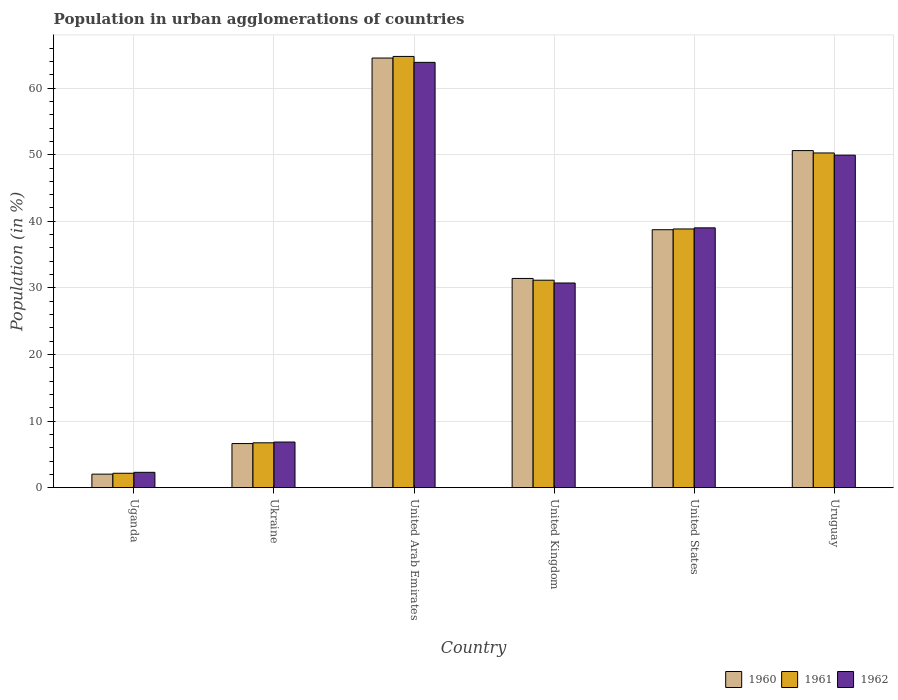How many different coloured bars are there?
Keep it short and to the point. 3. How many groups of bars are there?
Make the answer very short. 6. Are the number of bars on each tick of the X-axis equal?
Provide a short and direct response. Yes. How many bars are there on the 2nd tick from the right?
Your answer should be very brief. 3. What is the percentage of population in urban agglomerations in 1961 in Ukraine?
Give a very brief answer. 6.73. Across all countries, what is the maximum percentage of population in urban agglomerations in 1961?
Offer a very short reply. 64.75. Across all countries, what is the minimum percentage of population in urban agglomerations in 1962?
Provide a succinct answer. 2.3. In which country was the percentage of population in urban agglomerations in 1962 maximum?
Provide a short and direct response. United Arab Emirates. In which country was the percentage of population in urban agglomerations in 1962 minimum?
Give a very brief answer. Uganda. What is the total percentage of population in urban agglomerations in 1962 in the graph?
Offer a very short reply. 192.69. What is the difference between the percentage of population in urban agglomerations in 1960 in Ukraine and that in Uruguay?
Your answer should be compact. -44. What is the difference between the percentage of population in urban agglomerations in 1962 in United States and the percentage of population in urban agglomerations in 1961 in Uruguay?
Your answer should be very brief. -11.24. What is the average percentage of population in urban agglomerations in 1960 per country?
Your answer should be compact. 32.32. What is the difference between the percentage of population in urban agglomerations of/in 1960 and percentage of population in urban agglomerations of/in 1962 in United Arab Emirates?
Your answer should be compact. 0.65. What is the ratio of the percentage of population in urban agglomerations in 1962 in Ukraine to that in Uruguay?
Provide a succinct answer. 0.14. Is the difference between the percentage of population in urban agglomerations in 1960 in Ukraine and United States greater than the difference between the percentage of population in urban agglomerations in 1962 in Ukraine and United States?
Keep it short and to the point. Yes. What is the difference between the highest and the second highest percentage of population in urban agglomerations in 1960?
Give a very brief answer. 13.9. What is the difference between the highest and the lowest percentage of population in urban agglomerations in 1960?
Ensure brevity in your answer.  62.49. In how many countries, is the percentage of population in urban agglomerations in 1961 greater than the average percentage of population in urban agglomerations in 1961 taken over all countries?
Your response must be concise. 3. Is the sum of the percentage of population in urban agglomerations in 1961 in United Arab Emirates and United States greater than the maximum percentage of population in urban agglomerations in 1962 across all countries?
Offer a very short reply. Yes. How many bars are there?
Provide a succinct answer. 18. Are all the bars in the graph horizontal?
Offer a terse response. No. Are the values on the major ticks of Y-axis written in scientific E-notation?
Ensure brevity in your answer.  No. Does the graph contain any zero values?
Your answer should be very brief. No. Where does the legend appear in the graph?
Ensure brevity in your answer.  Bottom right. What is the title of the graph?
Give a very brief answer. Population in urban agglomerations of countries. Does "2009" appear as one of the legend labels in the graph?
Give a very brief answer. No. What is the label or title of the Y-axis?
Provide a short and direct response. Population (in %). What is the Population (in %) of 1960 in Uganda?
Give a very brief answer. 2.03. What is the Population (in %) in 1961 in Uganda?
Give a very brief answer. 2.16. What is the Population (in %) in 1962 in Uganda?
Provide a short and direct response. 2.3. What is the Population (in %) of 1960 in Ukraine?
Give a very brief answer. 6.62. What is the Population (in %) of 1961 in Ukraine?
Your response must be concise. 6.73. What is the Population (in %) of 1962 in Ukraine?
Offer a very short reply. 6.85. What is the Population (in %) in 1960 in United Arab Emirates?
Your response must be concise. 64.51. What is the Population (in %) in 1961 in United Arab Emirates?
Give a very brief answer. 64.75. What is the Population (in %) in 1962 in United Arab Emirates?
Offer a very short reply. 63.86. What is the Population (in %) of 1960 in United Kingdom?
Give a very brief answer. 31.42. What is the Population (in %) in 1961 in United Kingdom?
Your response must be concise. 31.15. What is the Population (in %) of 1962 in United Kingdom?
Provide a short and direct response. 30.73. What is the Population (in %) in 1960 in United States?
Provide a succinct answer. 38.73. What is the Population (in %) of 1961 in United States?
Make the answer very short. 38.85. What is the Population (in %) of 1962 in United States?
Provide a succinct answer. 39.01. What is the Population (in %) of 1960 in Uruguay?
Make the answer very short. 50.62. What is the Population (in %) of 1961 in Uruguay?
Your answer should be very brief. 50.26. What is the Population (in %) in 1962 in Uruguay?
Give a very brief answer. 49.93. Across all countries, what is the maximum Population (in %) of 1960?
Keep it short and to the point. 64.51. Across all countries, what is the maximum Population (in %) of 1961?
Ensure brevity in your answer.  64.75. Across all countries, what is the maximum Population (in %) in 1962?
Your response must be concise. 63.86. Across all countries, what is the minimum Population (in %) of 1960?
Ensure brevity in your answer.  2.03. Across all countries, what is the minimum Population (in %) in 1961?
Ensure brevity in your answer.  2.16. Across all countries, what is the minimum Population (in %) in 1962?
Provide a short and direct response. 2.3. What is the total Population (in %) in 1960 in the graph?
Offer a very short reply. 193.92. What is the total Population (in %) in 1961 in the graph?
Make the answer very short. 193.9. What is the total Population (in %) in 1962 in the graph?
Give a very brief answer. 192.69. What is the difference between the Population (in %) in 1960 in Uganda and that in Ukraine?
Ensure brevity in your answer.  -4.6. What is the difference between the Population (in %) in 1961 in Uganda and that in Ukraine?
Give a very brief answer. -4.57. What is the difference between the Population (in %) in 1962 in Uganda and that in Ukraine?
Keep it short and to the point. -4.55. What is the difference between the Population (in %) in 1960 in Uganda and that in United Arab Emirates?
Keep it short and to the point. -62.49. What is the difference between the Population (in %) in 1961 in Uganda and that in United Arab Emirates?
Provide a short and direct response. -62.59. What is the difference between the Population (in %) in 1962 in Uganda and that in United Arab Emirates?
Keep it short and to the point. -61.56. What is the difference between the Population (in %) of 1960 in Uganda and that in United Kingdom?
Provide a short and direct response. -29.39. What is the difference between the Population (in %) of 1961 in Uganda and that in United Kingdom?
Offer a terse response. -28.99. What is the difference between the Population (in %) of 1962 in Uganda and that in United Kingdom?
Offer a very short reply. -28.43. What is the difference between the Population (in %) of 1960 in Uganda and that in United States?
Offer a terse response. -36.71. What is the difference between the Population (in %) of 1961 in Uganda and that in United States?
Offer a terse response. -36.69. What is the difference between the Population (in %) in 1962 in Uganda and that in United States?
Your answer should be very brief. -36.71. What is the difference between the Population (in %) in 1960 in Uganda and that in Uruguay?
Give a very brief answer. -48.59. What is the difference between the Population (in %) of 1961 in Uganda and that in Uruguay?
Provide a short and direct response. -48.1. What is the difference between the Population (in %) in 1962 in Uganda and that in Uruguay?
Provide a short and direct response. -47.63. What is the difference between the Population (in %) of 1960 in Ukraine and that in United Arab Emirates?
Provide a succinct answer. -57.89. What is the difference between the Population (in %) of 1961 in Ukraine and that in United Arab Emirates?
Provide a succinct answer. -58.02. What is the difference between the Population (in %) in 1962 in Ukraine and that in United Arab Emirates?
Your answer should be very brief. -57.02. What is the difference between the Population (in %) in 1960 in Ukraine and that in United Kingdom?
Provide a short and direct response. -24.8. What is the difference between the Population (in %) in 1961 in Ukraine and that in United Kingdom?
Provide a short and direct response. -24.42. What is the difference between the Population (in %) of 1962 in Ukraine and that in United Kingdom?
Your answer should be compact. -23.88. What is the difference between the Population (in %) of 1960 in Ukraine and that in United States?
Keep it short and to the point. -32.11. What is the difference between the Population (in %) in 1961 in Ukraine and that in United States?
Your response must be concise. -32.11. What is the difference between the Population (in %) in 1962 in Ukraine and that in United States?
Offer a very short reply. -32.16. What is the difference between the Population (in %) of 1960 in Ukraine and that in Uruguay?
Offer a very short reply. -43.99. What is the difference between the Population (in %) in 1961 in Ukraine and that in Uruguay?
Make the answer very short. -43.52. What is the difference between the Population (in %) of 1962 in Ukraine and that in Uruguay?
Keep it short and to the point. -43.08. What is the difference between the Population (in %) in 1960 in United Arab Emirates and that in United Kingdom?
Your answer should be compact. 33.1. What is the difference between the Population (in %) in 1961 in United Arab Emirates and that in United Kingdom?
Give a very brief answer. 33.6. What is the difference between the Population (in %) of 1962 in United Arab Emirates and that in United Kingdom?
Your answer should be compact. 33.13. What is the difference between the Population (in %) of 1960 in United Arab Emirates and that in United States?
Ensure brevity in your answer.  25.78. What is the difference between the Population (in %) of 1961 in United Arab Emirates and that in United States?
Offer a very short reply. 25.91. What is the difference between the Population (in %) of 1962 in United Arab Emirates and that in United States?
Offer a terse response. 24.85. What is the difference between the Population (in %) in 1960 in United Arab Emirates and that in Uruguay?
Your answer should be very brief. 13.9. What is the difference between the Population (in %) in 1961 in United Arab Emirates and that in Uruguay?
Ensure brevity in your answer.  14.5. What is the difference between the Population (in %) in 1962 in United Arab Emirates and that in Uruguay?
Offer a terse response. 13.94. What is the difference between the Population (in %) in 1960 in United Kingdom and that in United States?
Your answer should be very brief. -7.32. What is the difference between the Population (in %) in 1961 in United Kingdom and that in United States?
Your answer should be compact. -7.7. What is the difference between the Population (in %) of 1962 in United Kingdom and that in United States?
Your response must be concise. -8.28. What is the difference between the Population (in %) of 1960 in United Kingdom and that in Uruguay?
Make the answer very short. -19.2. What is the difference between the Population (in %) of 1961 in United Kingdom and that in Uruguay?
Offer a terse response. -19.11. What is the difference between the Population (in %) in 1962 in United Kingdom and that in Uruguay?
Your answer should be compact. -19.2. What is the difference between the Population (in %) of 1960 in United States and that in Uruguay?
Keep it short and to the point. -11.88. What is the difference between the Population (in %) of 1961 in United States and that in Uruguay?
Keep it short and to the point. -11.41. What is the difference between the Population (in %) in 1962 in United States and that in Uruguay?
Your response must be concise. -10.91. What is the difference between the Population (in %) of 1960 in Uganda and the Population (in %) of 1961 in Ukraine?
Keep it short and to the point. -4.71. What is the difference between the Population (in %) in 1960 in Uganda and the Population (in %) in 1962 in Ukraine?
Your answer should be compact. -4.82. What is the difference between the Population (in %) in 1961 in Uganda and the Population (in %) in 1962 in Ukraine?
Keep it short and to the point. -4.69. What is the difference between the Population (in %) in 1960 in Uganda and the Population (in %) in 1961 in United Arab Emirates?
Keep it short and to the point. -62.73. What is the difference between the Population (in %) in 1960 in Uganda and the Population (in %) in 1962 in United Arab Emirates?
Provide a short and direct response. -61.84. What is the difference between the Population (in %) in 1961 in Uganda and the Population (in %) in 1962 in United Arab Emirates?
Provide a short and direct response. -61.7. What is the difference between the Population (in %) in 1960 in Uganda and the Population (in %) in 1961 in United Kingdom?
Your response must be concise. -29.12. What is the difference between the Population (in %) of 1960 in Uganda and the Population (in %) of 1962 in United Kingdom?
Ensure brevity in your answer.  -28.71. What is the difference between the Population (in %) of 1961 in Uganda and the Population (in %) of 1962 in United Kingdom?
Provide a short and direct response. -28.57. What is the difference between the Population (in %) in 1960 in Uganda and the Population (in %) in 1961 in United States?
Provide a short and direct response. -36.82. What is the difference between the Population (in %) in 1960 in Uganda and the Population (in %) in 1962 in United States?
Your response must be concise. -36.99. What is the difference between the Population (in %) in 1961 in Uganda and the Population (in %) in 1962 in United States?
Offer a terse response. -36.85. What is the difference between the Population (in %) in 1960 in Uganda and the Population (in %) in 1961 in Uruguay?
Provide a succinct answer. -48.23. What is the difference between the Population (in %) in 1960 in Uganda and the Population (in %) in 1962 in Uruguay?
Offer a very short reply. -47.9. What is the difference between the Population (in %) in 1961 in Uganda and the Population (in %) in 1962 in Uruguay?
Keep it short and to the point. -47.77. What is the difference between the Population (in %) of 1960 in Ukraine and the Population (in %) of 1961 in United Arab Emirates?
Keep it short and to the point. -58.13. What is the difference between the Population (in %) in 1960 in Ukraine and the Population (in %) in 1962 in United Arab Emirates?
Ensure brevity in your answer.  -57.24. What is the difference between the Population (in %) in 1961 in Ukraine and the Population (in %) in 1962 in United Arab Emirates?
Ensure brevity in your answer.  -57.13. What is the difference between the Population (in %) of 1960 in Ukraine and the Population (in %) of 1961 in United Kingdom?
Your response must be concise. -24.53. What is the difference between the Population (in %) in 1960 in Ukraine and the Population (in %) in 1962 in United Kingdom?
Offer a very short reply. -24.11. What is the difference between the Population (in %) in 1961 in Ukraine and the Population (in %) in 1962 in United Kingdom?
Your response must be concise. -24. What is the difference between the Population (in %) of 1960 in Ukraine and the Population (in %) of 1961 in United States?
Give a very brief answer. -32.23. What is the difference between the Population (in %) in 1960 in Ukraine and the Population (in %) in 1962 in United States?
Your answer should be very brief. -32.39. What is the difference between the Population (in %) in 1961 in Ukraine and the Population (in %) in 1962 in United States?
Keep it short and to the point. -32.28. What is the difference between the Population (in %) of 1960 in Ukraine and the Population (in %) of 1961 in Uruguay?
Give a very brief answer. -43.64. What is the difference between the Population (in %) in 1960 in Ukraine and the Population (in %) in 1962 in Uruguay?
Your response must be concise. -43.31. What is the difference between the Population (in %) in 1961 in Ukraine and the Population (in %) in 1962 in Uruguay?
Your response must be concise. -43.19. What is the difference between the Population (in %) in 1960 in United Arab Emirates and the Population (in %) in 1961 in United Kingdom?
Provide a short and direct response. 33.36. What is the difference between the Population (in %) of 1960 in United Arab Emirates and the Population (in %) of 1962 in United Kingdom?
Your answer should be very brief. 33.78. What is the difference between the Population (in %) in 1961 in United Arab Emirates and the Population (in %) in 1962 in United Kingdom?
Your answer should be compact. 34.02. What is the difference between the Population (in %) in 1960 in United Arab Emirates and the Population (in %) in 1961 in United States?
Provide a short and direct response. 25.67. What is the difference between the Population (in %) of 1960 in United Arab Emirates and the Population (in %) of 1962 in United States?
Keep it short and to the point. 25.5. What is the difference between the Population (in %) in 1961 in United Arab Emirates and the Population (in %) in 1962 in United States?
Provide a short and direct response. 25.74. What is the difference between the Population (in %) in 1960 in United Arab Emirates and the Population (in %) in 1961 in Uruguay?
Keep it short and to the point. 14.26. What is the difference between the Population (in %) of 1960 in United Arab Emirates and the Population (in %) of 1962 in Uruguay?
Provide a succinct answer. 14.59. What is the difference between the Population (in %) in 1961 in United Arab Emirates and the Population (in %) in 1962 in Uruguay?
Keep it short and to the point. 14.83. What is the difference between the Population (in %) in 1960 in United Kingdom and the Population (in %) in 1961 in United States?
Your response must be concise. -7.43. What is the difference between the Population (in %) of 1960 in United Kingdom and the Population (in %) of 1962 in United States?
Your response must be concise. -7.6. What is the difference between the Population (in %) in 1961 in United Kingdom and the Population (in %) in 1962 in United States?
Make the answer very short. -7.86. What is the difference between the Population (in %) in 1960 in United Kingdom and the Population (in %) in 1961 in Uruguay?
Provide a succinct answer. -18.84. What is the difference between the Population (in %) in 1960 in United Kingdom and the Population (in %) in 1962 in Uruguay?
Ensure brevity in your answer.  -18.51. What is the difference between the Population (in %) in 1961 in United Kingdom and the Population (in %) in 1962 in Uruguay?
Your answer should be very brief. -18.78. What is the difference between the Population (in %) of 1960 in United States and the Population (in %) of 1961 in Uruguay?
Provide a succinct answer. -11.53. What is the difference between the Population (in %) in 1960 in United States and the Population (in %) in 1962 in Uruguay?
Offer a very short reply. -11.2. What is the difference between the Population (in %) in 1961 in United States and the Population (in %) in 1962 in Uruguay?
Keep it short and to the point. -11.08. What is the average Population (in %) of 1960 per country?
Your answer should be very brief. 32.32. What is the average Population (in %) in 1961 per country?
Keep it short and to the point. 32.32. What is the average Population (in %) in 1962 per country?
Give a very brief answer. 32.11. What is the difference between the Population (in %) of 1960 and Population (in %) of 1961 in Uganda?
Provide a succinct answer. -0.13. What is the difference between the Population (in %) in 1960 and Population (in %) in 1962 in Uganda?
Provide a short and direct response. -0.28. What is the difference between the Population (in %) in 1961 and Population (in %) in 1962 in Uganda?
Ensure brevity in your answer.  -0.14. What is the difference between the Population (in %) in 1960 and Population (in %) in 1961 in Ukraine?
Provide a succinct answer. -0.11. What is the difference between the Population (in %) in 1960 and Population (in %) in 1962 in Ukraine?
Offer a very short reply. -0.23. What is the difference between the Population (in %) in 1961 and Population (in %) in 1962 in Ukraine?
Ensure brevity in your answer.  -0.12. What is the difference between the Population (in %) of 1960 and Population (in %) of 1961 in United Arab Emirates?
Make the answer very short. -0.24. What is the difference between the Population (in %) of 1960 and Population (in %) of 1962 in United Arab Emirates?
Make the answer very short. 0.65. What is the difference between the Population (in %) of 1961 and Population (in %) of 1962 in United Arab Emirates?
Provide a short and direct response. 0.89. What is the difference between the Population (in %) of 1960 and Population (in %) of 1961 in United Kingdom?
Your answer should be very brief. 0.27. What is the difference between the Population (in %) of 1960 and Population (in %) of 1962 in United Kingdom?
Offer a terse response. 0.68. What is the difference between the Population (in %) in 1961 and Population (in %) in 1962 in United Kingdom?
Your response must be concise. 0.42. What is the difference between the Population (in %) in 1960 and Population (in %) in 1961 in United States?
Your response must be concise. -0.11. What is the difference between the Population (in %) in 1960 and Population (in %) in 1962 in United States?
Give a very brief answer. -0.28. What is the difference between the Population (in %) in 1960 and Population (in %) in 1961 in Uruguay?
Give a very brief answer. 0.36. What is the difference between the Population (in %) of 1960 and Population (in %) of 1962 in Uruguay?
Provide a short and direct response. 0.69. What is the difference between the Population (in %) of 1961 and Population (in %) of 1962 in Uruguay?
Offer a very short reply. 0.33. What is the ratio of the Population (in %) in 1960 in Uganda to that in Ukraine?
Provide a short and direct response. 0.31. What is the ratio of the Population (in %) in 1961 in Uganda to that in Ukraine?
Provide a short and direct response. 0.32. What is the ratio of the Population (in %) in 1962 in Uganda to that in Ukraine?
Your answer should be very brief. 0.34. What is the ratio of the Population (in %) of 1960 in Uganda to that in United Arab Emirates?
Offer a very short reply. 0.03. What is the ratio of the Population (in %) in 1961 in Uganda to that in United Arab Emirates?
Your response must be concise. 0.03. What is the ratio of the Population (in %) of 1962 in Uganda to that in United Arab Emirates?
Your response must be concise. 0.04. What is the ratio of the Population (in %) in 1960 in Uganda to that in United Kingdom?
Offer a very short reply. 0.06. What is the ratio of the Population (in %) in 1961 in Uganda to that in United Kingdom?
Provide a succinct answer. 0.07. What is the ratio of the Population (in %) of 1962 in Uganda to that in United Kingdom?
Keep it short and to the point. 0.07. What is the ratio of the Population (in %) in 1960 in Uganda to that in United States?
Make the answer very short. 0.05. What is the ratio of the Population (in %) in 1961 in Uganda to that in United States?
Give a very brief answer. 0.06. What is the ratio of the Population (in %) of 1962 in Uganda to that in United States?
Make the answer very short. 0.06. What is the ratio of the Population (in %) of 1961 in Uganda to that in Uruguay?
Provide a succinct answer. 0.04. What is the ratio of the Population (in %) of 1962 in Uganda to that in Uruguay?
Your answer should be compact. 0.05. What is the ratio of the Population (in %) of 1960 in Ukraine to that in United Arab Emirates?
Your answer should be very brief. 0.1. What is the ratio of the Population (in %) in 1961 in Ukraine to that in United Arab Emirates?
Make the answer very short. 0.1. What is the ratio of the Population (in %) of 1962 in Ukraine to that in United Arab Emirates?
Give a very brief answer. 0.11. What is the ratio of the Population (in %) in 1960 in Ukraine to that in United Kingdom?
Provide a short and direct response. 0.21. What is the ratio of the Population (in %) in 1961 in Ukraine to that in United Kingdom?
Your answer should be compact. 0.22. What is the ratio of the Population (in %) of 1962 in Ukraine to that in United Kingdom?
Provide a short and direct response. 0.22. What is the ratio of the Population (in %) in 1960 in Ukraine to that in United States?
Offer a very short reply. 0.17. What is the ratio of the Population (in %) of 1961 in Ukraine to that in United States?
Make the answer very short. 0.17. What is the ratio of the Population (in %) of 1962 in Ukraine to that in United States?
Make the answer very short. 0.18. What is the ratio of the Population (in %) of 1960 in Ukraine to that in Uruguay?
Offer a terse response. 0.13. What is the ratio of the Population (in %) in 1961 in Ukraine to that in Uruguay?
Give a very brief answer. 0.13. What is the ratio of the Population (in %) in 1962 in Ukraine to that in Uruguay?
Offer a terse response. 0.14. What is the ratio of the Population (in %) of 1960 in United Arab Emirates to that in United Kingdom?
Ensure brevity in your answer.  2.05. What is the ratio of the Population (in %) of 1961 in United Arab Emirates to that in United Kingdom?
Keep it short and to the point. 2.08. What is the ratio of the Population (in %) in 1962 in United Arab Emirates to that in United Kingdom?
Provide a succinct answer. 2.08. What is the ratio of the Population (in %) in 1960 in United Arab Emirates to that in United States?
Make the answer very short. 1.67. What is the ratio of the Population (in %) of 1961 in United Arab Emirates to that in United States?
Provide a short and direct response. 1.67. What is the ratio of the Population (in %) of 1962 in United Arab Emirates to that in United States?
Your answer should be very brief. 1.64. What is the ratio of the Population (in %) in 1960 in United Arab Emirates to that in Uruguay?
Offer a terse response. 1.27. What is the ratio of the Population (in %) of 1961 in United Arab Emirates to that in Uruguay?
Your response must be concise. 1.29. What is the ratio of the Population (in %) of 1962 in United Arab Emirates to that in Uruguay?
Offer a very short reply. 1.28. What is the ratio of the Population (in %) in 1960 in United Kingdom to that in United States?
Provide a short and direct response. 0.81. What is the ratio of the Population (in %) in 1961 in United Kingdom to that in United States?
Provide a short and direct response. 0.8. What is the ratio of the Population (in %) of 1962 in United Kingdom to that in United States?
Give a very brief answer. 0.79. What is the ratio of the Population (in %) in 1960 in United Kingdom to that in Uruguay?
Provide a short and direct response. 0.62. What is the ratio of the Population (in %) of 1961 in United Kingdom to that in Uruguay?
Your answer should be compact. 0.62. What is the ratio of the Population (in %) of 1962 in United Kingdom to that in Uruguay?
Make the answer very short. 0.62. What is the ratio of the Population (in %) of 1960 in United States to that in Uruguay?
Your response must be concise. 0.77. What is the ratio of the Population (in %) of 1961 in United States to that in Uruguay?
Ensure brevity in your answer.  0.77. What is the ratio of the Population (in %) of 1962 in United States to that in Uruguay?
Offer a very short reply. 0.78. What is the difference between the highest and the second highest Population (in %) of 1960?
Provide a succinct answer. 13.9. What is the difference between the highest and the second highest Population (in %) in 1961?
Provide a short and direct response. 14.5. What is the difference between the highest and the second highest Population (in %) of 1962?
Offer a terse response. 13.94. What is the difference between the highest and the lowest Population (in %) of 1960?
Give a very brief answer. 62.49. What is the difference between the highest and the lowest Population (in %) in 1961?
Make the answer very short. 62.59. What is the difference between the highest and the lowest Population (in %) in 1962?
Keep it short and to the point. 61.56. 